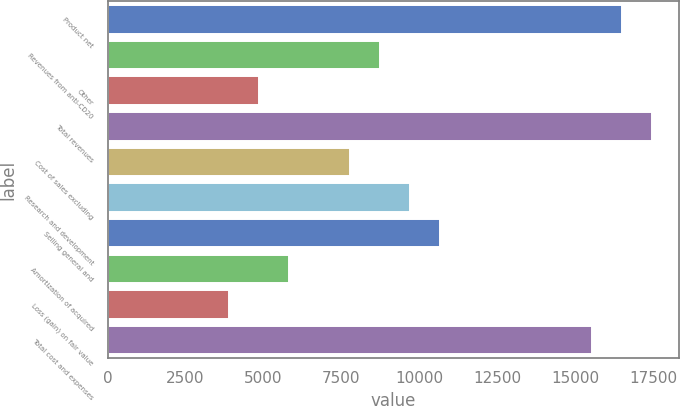Convert chart to OTSL. <chart><loc_0><loc_0><loc_500><loc_500><bar_chart><fcel>Product net<fcel>Revenues from anti-CD20<fcel>Other<fcel>Total revenues<fcel>Cost of sales excluding<fcel>Research and development<fcel>Selling general and<fcel>Amortization of acquired<fcel>Loss (gain) on fair value<fcel>Total cost and expenses<nl><fcel>16490.8<fcel>8733.65<fcel>4855.05<fcel>17460.5<fcel>7764<fcel>9703.3<fcel>10673<fcel>5824.7<fcel>3885.4<fcel>15521.2<nl></chart> 